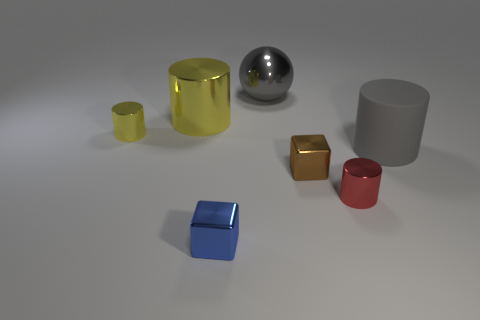What number of tiny things are made of the same material as the large yellow cylinder?
Your answer should be very brief. 4. Does the yellow object that is in front of the large yellow cylinder have the same material as the small cube that is on the right side of the tiny blue block?
Ensure brevity in your answer.  Yes. There is a big cylinder that is to the left of the small metal cylinder that is in front of the large gray rubber cylinder; how many shiny objects are right of it?
Offer a very short reply. 4. There is a shiny thing in front of the red metal cylinder; does it have the same color as the metallic sphere that is behind the red cylinder?
Ensure brevity in your answer.  No. Is there any other thing that is the same color as the matte object?
Your response must be concise. Yes. There is a cube behind the small metallic cube in front of the brown thing; what color is it?
Your response must be concise. Brown. Are there any metallic things?
Ensure brevity in your answer.  Yes. There is a cylinder that is both on the left side of the gray matte thing and in front of the tiny yellow metallic cylinder; what is its color?
Ensure brevity in your answer.  Red. There is a red cylinder on the right side of the small blue metal object; is its size the same as the gray thing that is to the left of the large gray cylinder?
Give a very brief answer. No. How many other things are there of the same size as the blue metal block?
Your answer should be very brief. 3. 